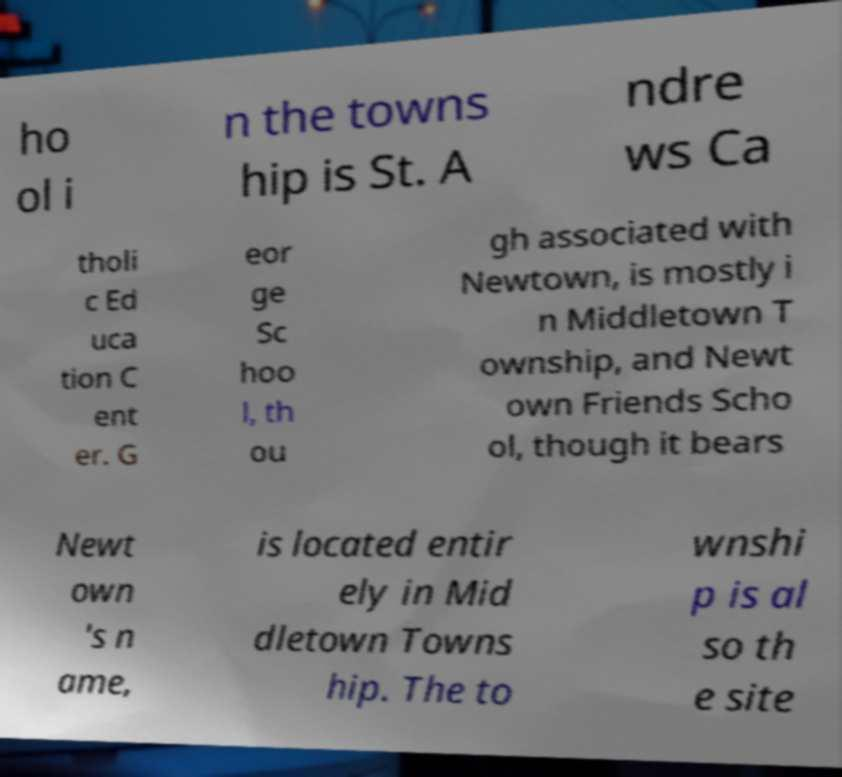Can you accurately transcribe the text from the provided image for me? ho ol i n the towns hip is St. A ndre ws Ca tholi c Ed uca tion C ent er. G eor ge Sc hoo l, th ou gh associated with Newtown, is mostly i n Middletown T ownship, and Newt own Friends Scho ol, though it bears Newt own 's n ame, is located entir ely in Mid dletown Towns hip. The to wnshi p is al so th e site 